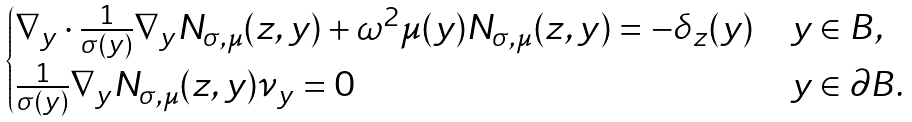Convert formula to latex. <formula><loc_0><loc_0><loc_500><loc_500>\begin{cases} \nabla _ { y } \cdot \frac { 1 } { \sigma ( y ) } \nabla _ { y } N _ { \sigma , \mu } ( z , y ) + \omega ^ { 2 } \mu ( y ) N _ { \sigma , \mu } ( z , y ) = - \delta _ { z } ( y ) & y \in B , \\ \frac { 1 } { \sigma ( y ) } \nabla _ { y } N _ { \sigma , \mu } ( z , y ) \nu _ { y } = 0 & y \in \partial B . \end{cases}</formula> 